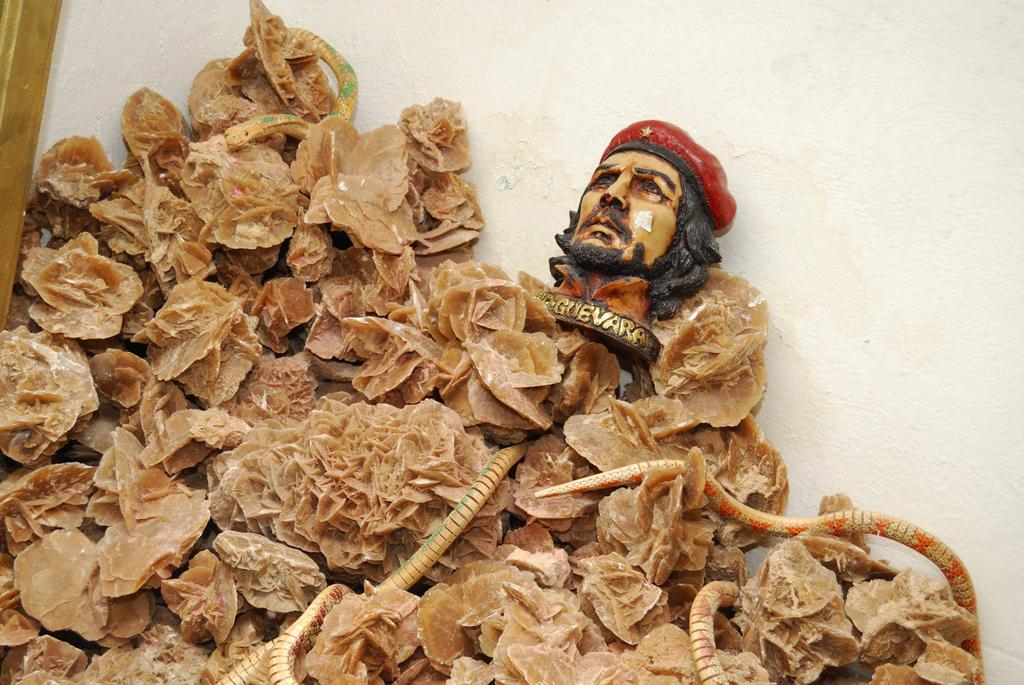What is the main subject of the image? There is a showpiece in the image. What is depicted on the showpiece? The showpiece has a man's face and flowers. What type of shirt is the man wearing in the image? There is no man wearing a shirt in the image; the man's face is part of the showpiece. 